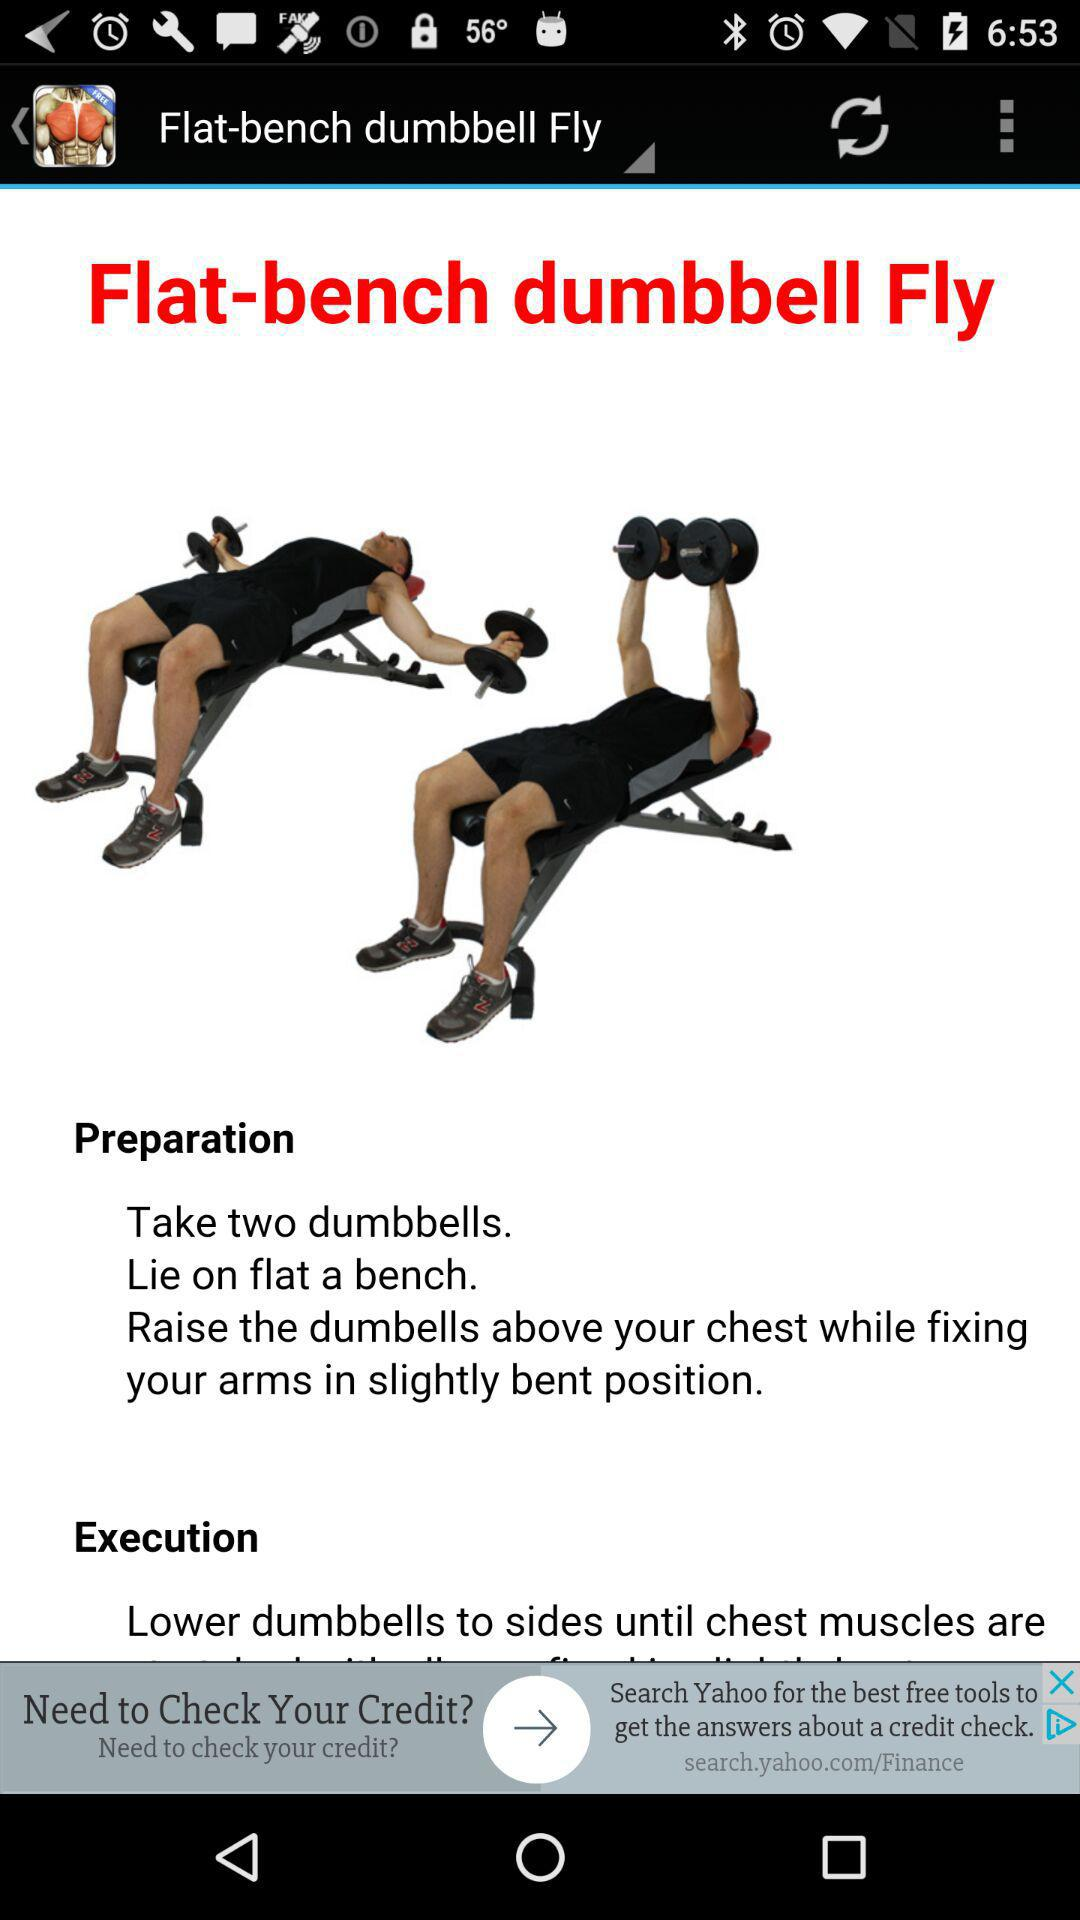What is the exercise name? The exercise name is Flat-bench Dumbbell Fly. 